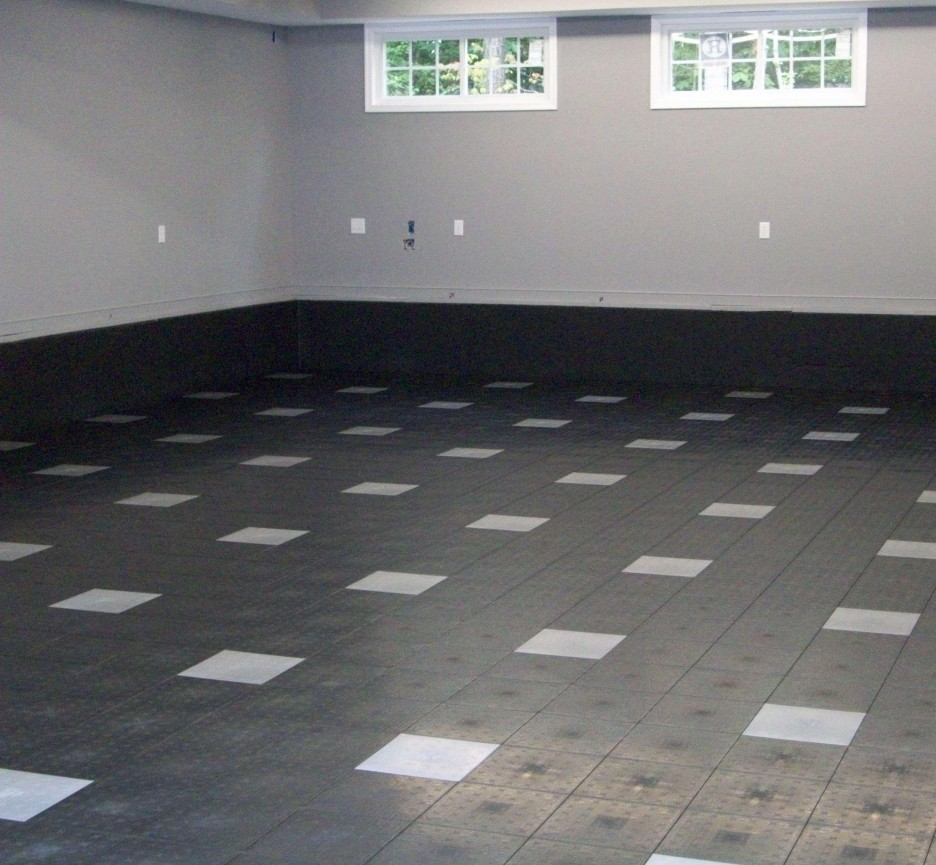What specific design elements could indicate this room's suitability for being a dance studio? The spacious layout and smooth, checkerboard pattern flooring are key elements that make this room suitable for a dance studio. The floor's durable, flat surface is ideal for various dance styles, ensuring safety and ease of movement. Large windows allow for natural light, which can be inspiring and energizing for dancers. Additionally, the room's isolation (likely being a basement) minimizes disturbances from other house activities, providing a focused environment for rehearsals. 